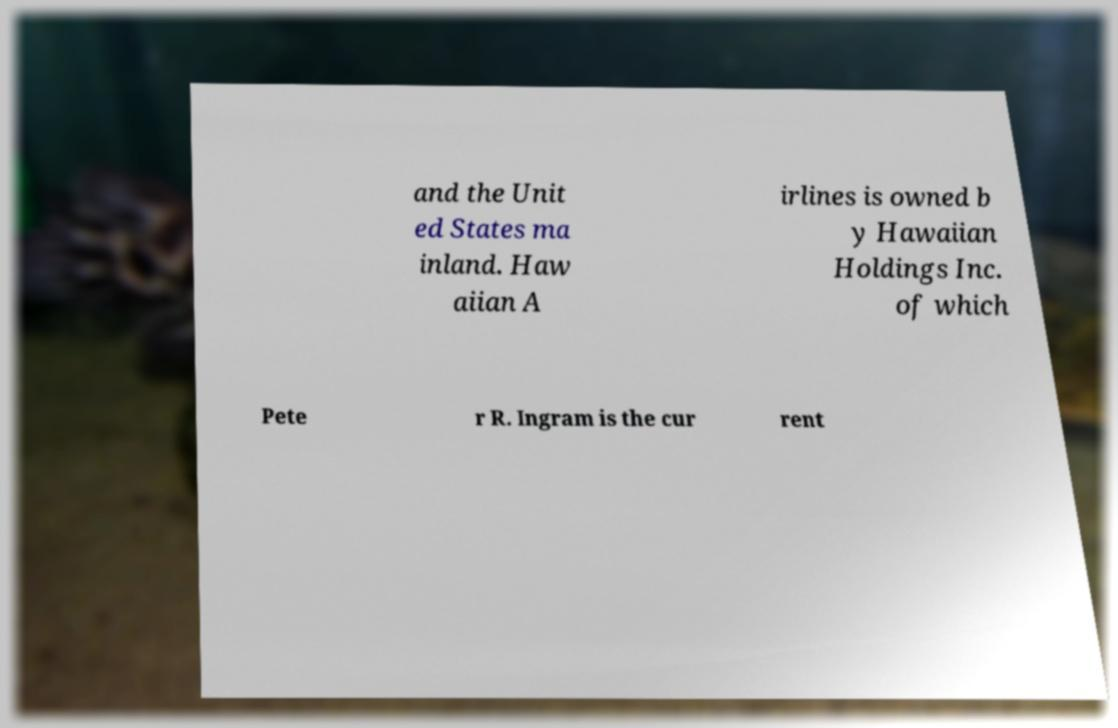For documentation purposes, I need the text within this image transcribed. Could you provide that? and the Unit ed States ma inland. Haw aiian A irlines is owned b y Hawaiian Holdings Inc. of which Pete r R. Ingram is the cur rent 